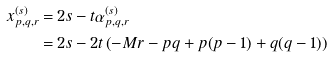Convert formula to latex. <formula><loc_0><loc_0><loc_500><loc_500>x ^ { ( s ) } _ { p , q , r } = & \, 2 s - t \alpha ^ { ( s ) } _ { p , q , r } \\ = & \, 2 s - 2 t \left ( - M r - p q + p ( p - 1 ) + q ( q - 1 ) \right )</formula> 